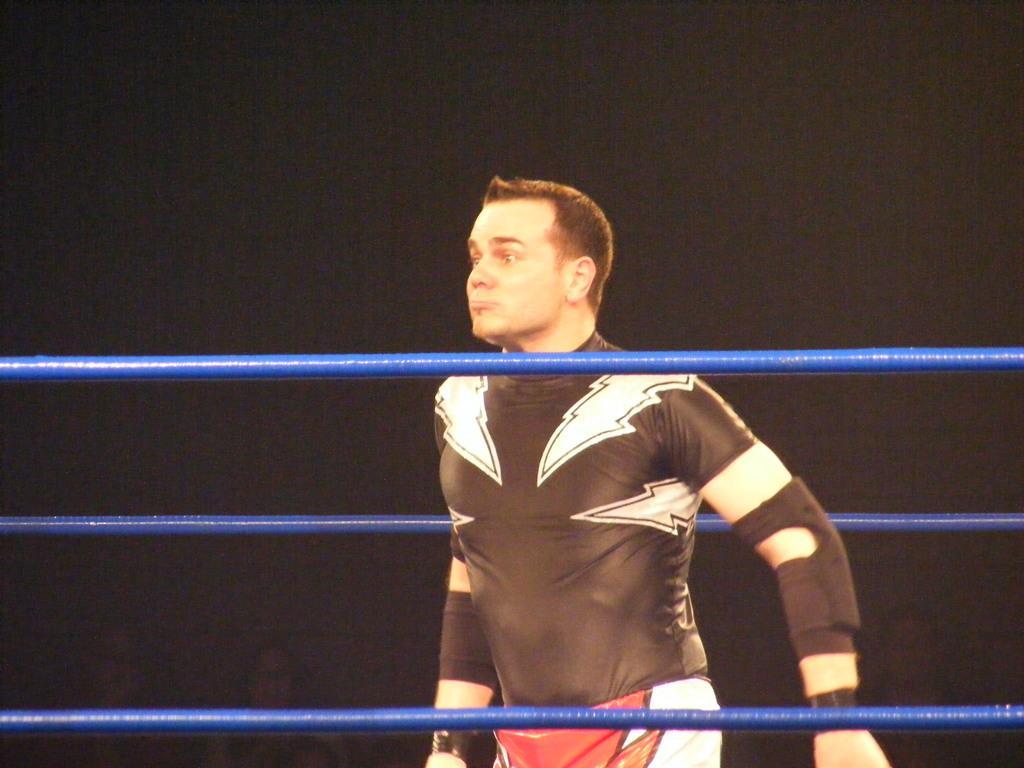Could you give a brief overview of what you see in this image? In this image I can see a person wearing black, white and red colored dress is standing in the wrestling ring. I can see blue colored ropes and the black colored background. 